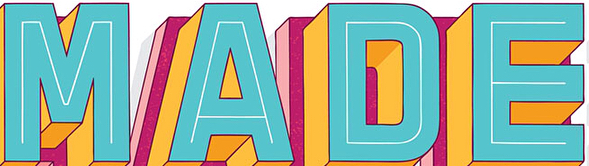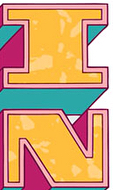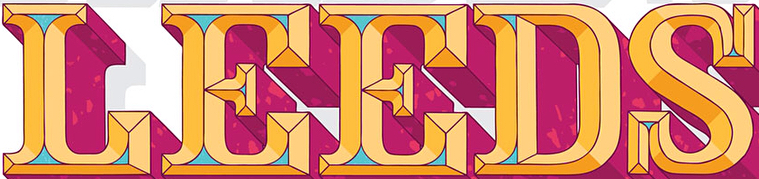What text appears in these images from left to right, separated by a semicolon? MADE; IN; LEEDS 